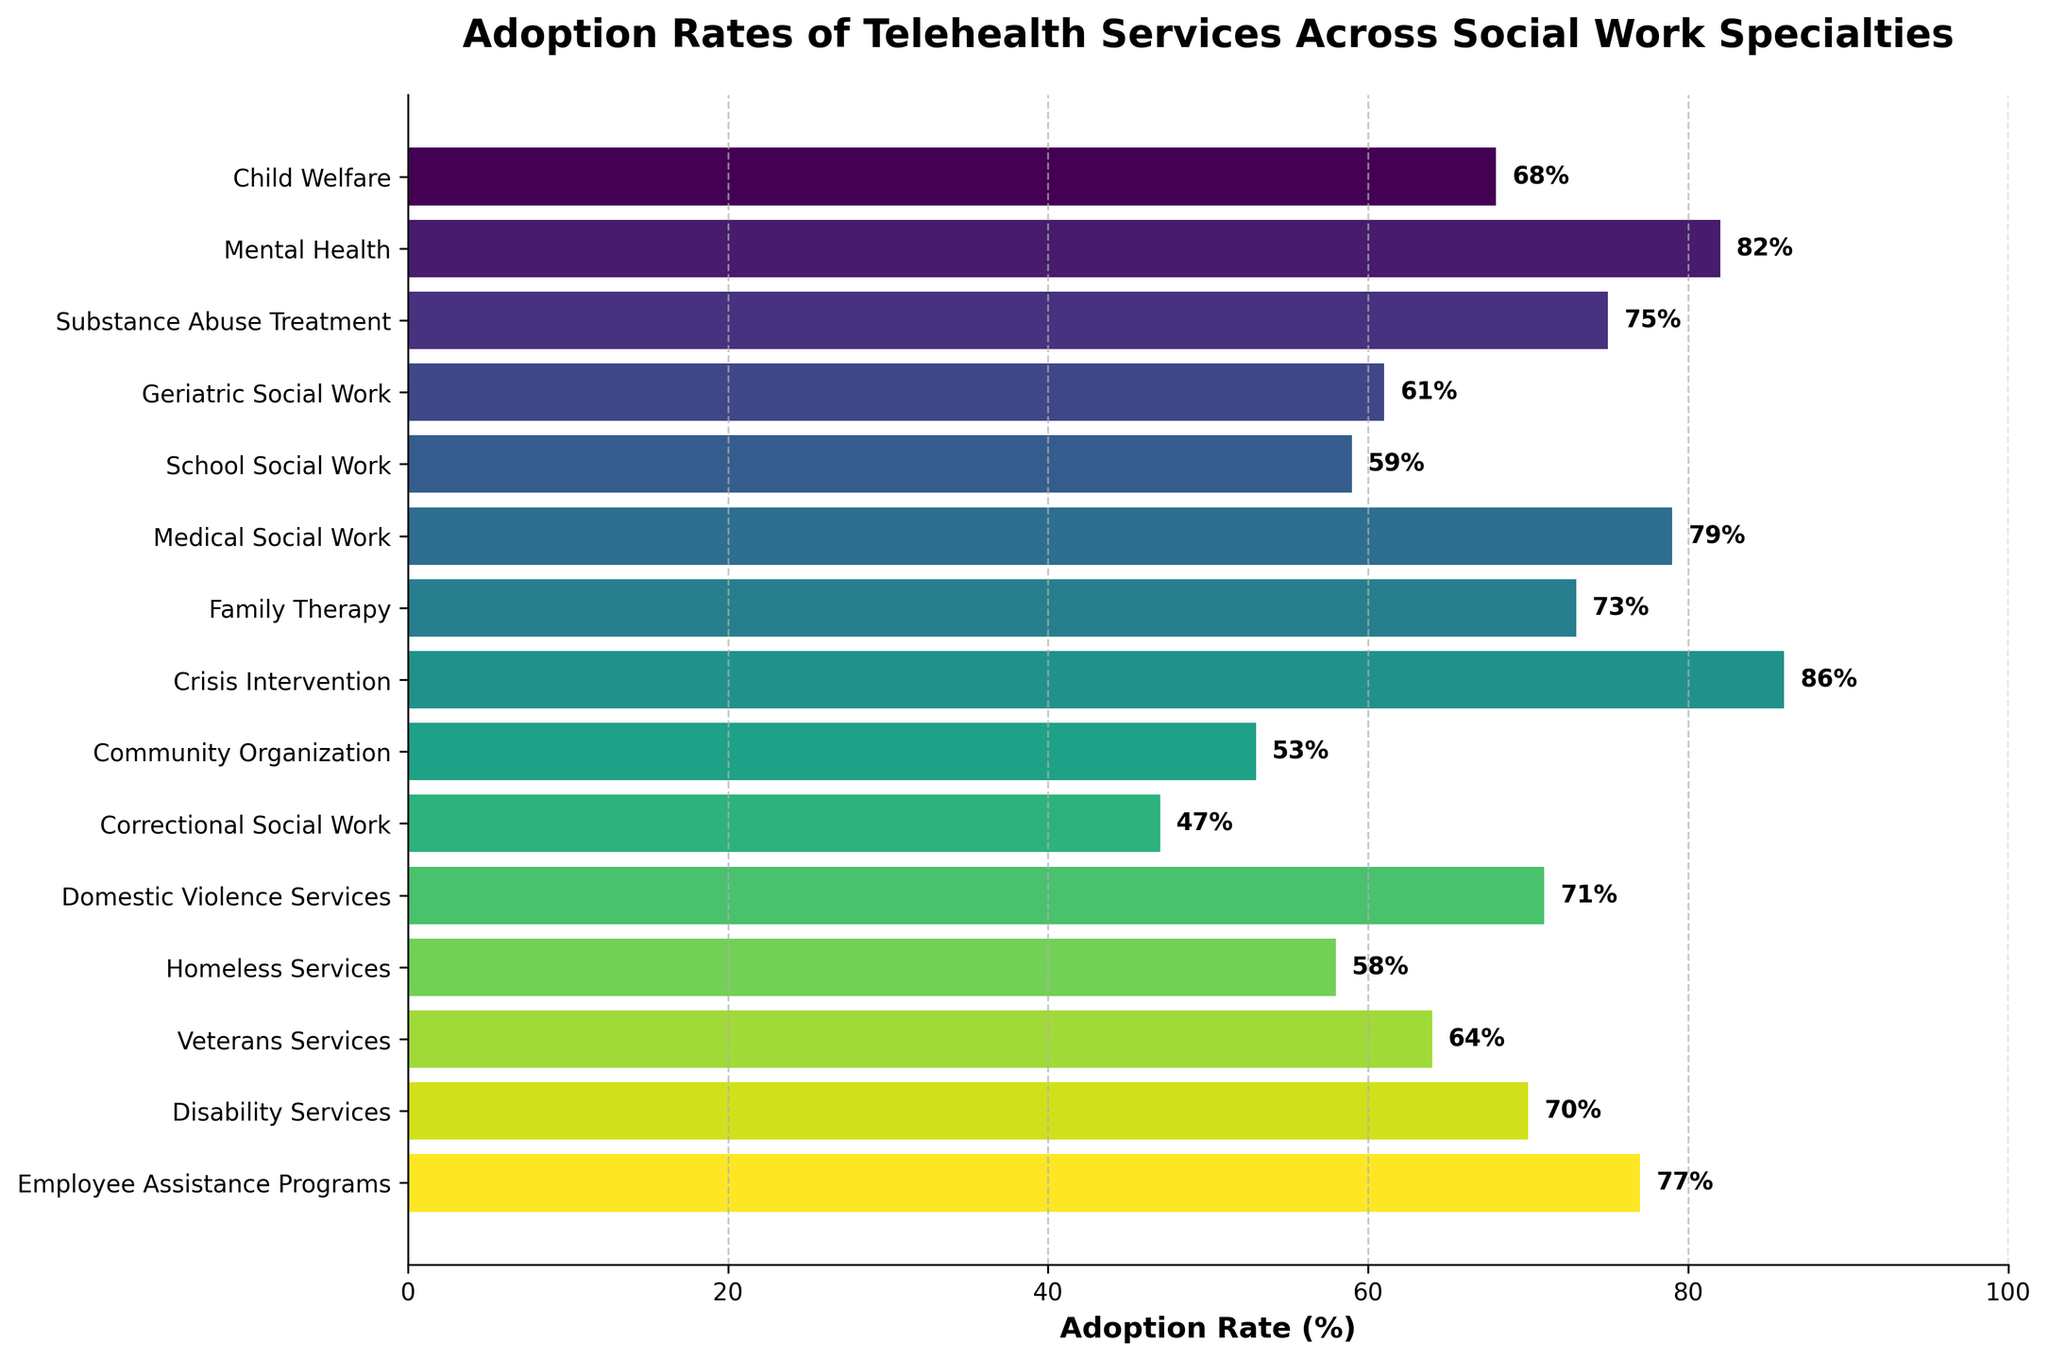Which social work specialty has the highest adoption rate of telehealth services? Look for the bar that extends the furthest to the right. Crisis Intervention has the highest adoption rate with 86%.
Answer: Crisis Intervention with 86% Which social work specialty has the lowest adoption rate of telehealth services? Look for the bar that is the shortest. Correctional Social Work has the lowest adoption rate with 47%.
Answer: Correctional Social Work What's the average adoption rate of telehealth services for Child Welfare, Mental Health, and Substance Abuse Treatment? Calculate the average of the three adoption rates: (68 + 82 + 75)/3 = 75
Answer: 75 Which has a higher adoption rate: Domestic Violence Services or Employee Assistance Programs? Compare the lengths of the bars for Domestic Violence Services (71%) and Employee Assistance Programs (77%). Employee Assistance Programs has the higher adoption rate.
Answer: Employee Assistance Programs Are there any social work specialties with an adoption rate below 50%? Check all bars to see which, if any, have lengths corresponding to less than 50%. Only Correctional Social Work has an adoption rate below 50% with 47%.
Answer: Yes, Correctional Social Work How many social work specialties have an adoption rate above 70%? Count the number of bars that extend beyond the 70% mark. There are 8 specialties above 70%.
Answer: 8 What's the combined adoption rate of Geriatric Social Work, School Social Work, and Community Organization? Add the adoption rates of the three specialties: 61 + 59 + 53 = 173
Answer: 173 Is the adoption rate for Homeless Services higher or lower than the adoption rate for Veterans Services? Compare the lengths of the bars for Homeless Services (58%) and Veterans Services (64%). Veterans Services has a higher adoption rate.
Answer: Lower What is the median adoption rate among all the social work specialties? Sort the adoption rates in ascending order and find the middle value. In ascending order, the rates are: 47, 53, 58, 59, 61, 64, 68, 70, 71, 73, 75, 77, 79, 82, 86. The median value is 70.
Answer: 70 Which social work specialty has an adoption rate closest to the average adoption rate of all specialties? First, calculate the average adoption rate of all specialties: (68 + 82 + 75 + 61 + 59 + 79 + 73 + 86 + 53 + 47 + 71 + 58 + 64 + 70 + 77)/15 = ~68.87. Then, find the specialty with the adoption rate closest to this value. Child Welfare has an adoption rate of 68, which is closest to the average.
Answer: Child Welfare 